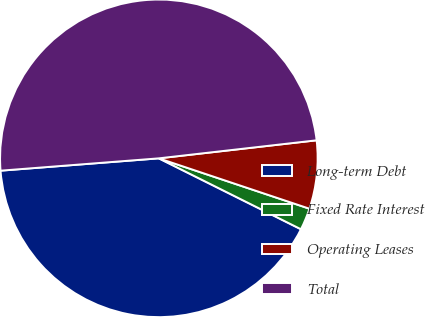<chart> <loc_0><loc_0><loc_500><loc_500><pie_chart><fcel>Long-term Debt<fcel>Fixed Rate Interest<fcel>Operating Leases<fcel>Total<nl><fcel>41.4%<fcel>2.23%<fcel>6.95%<fcel>49.43%<nl></chart> 